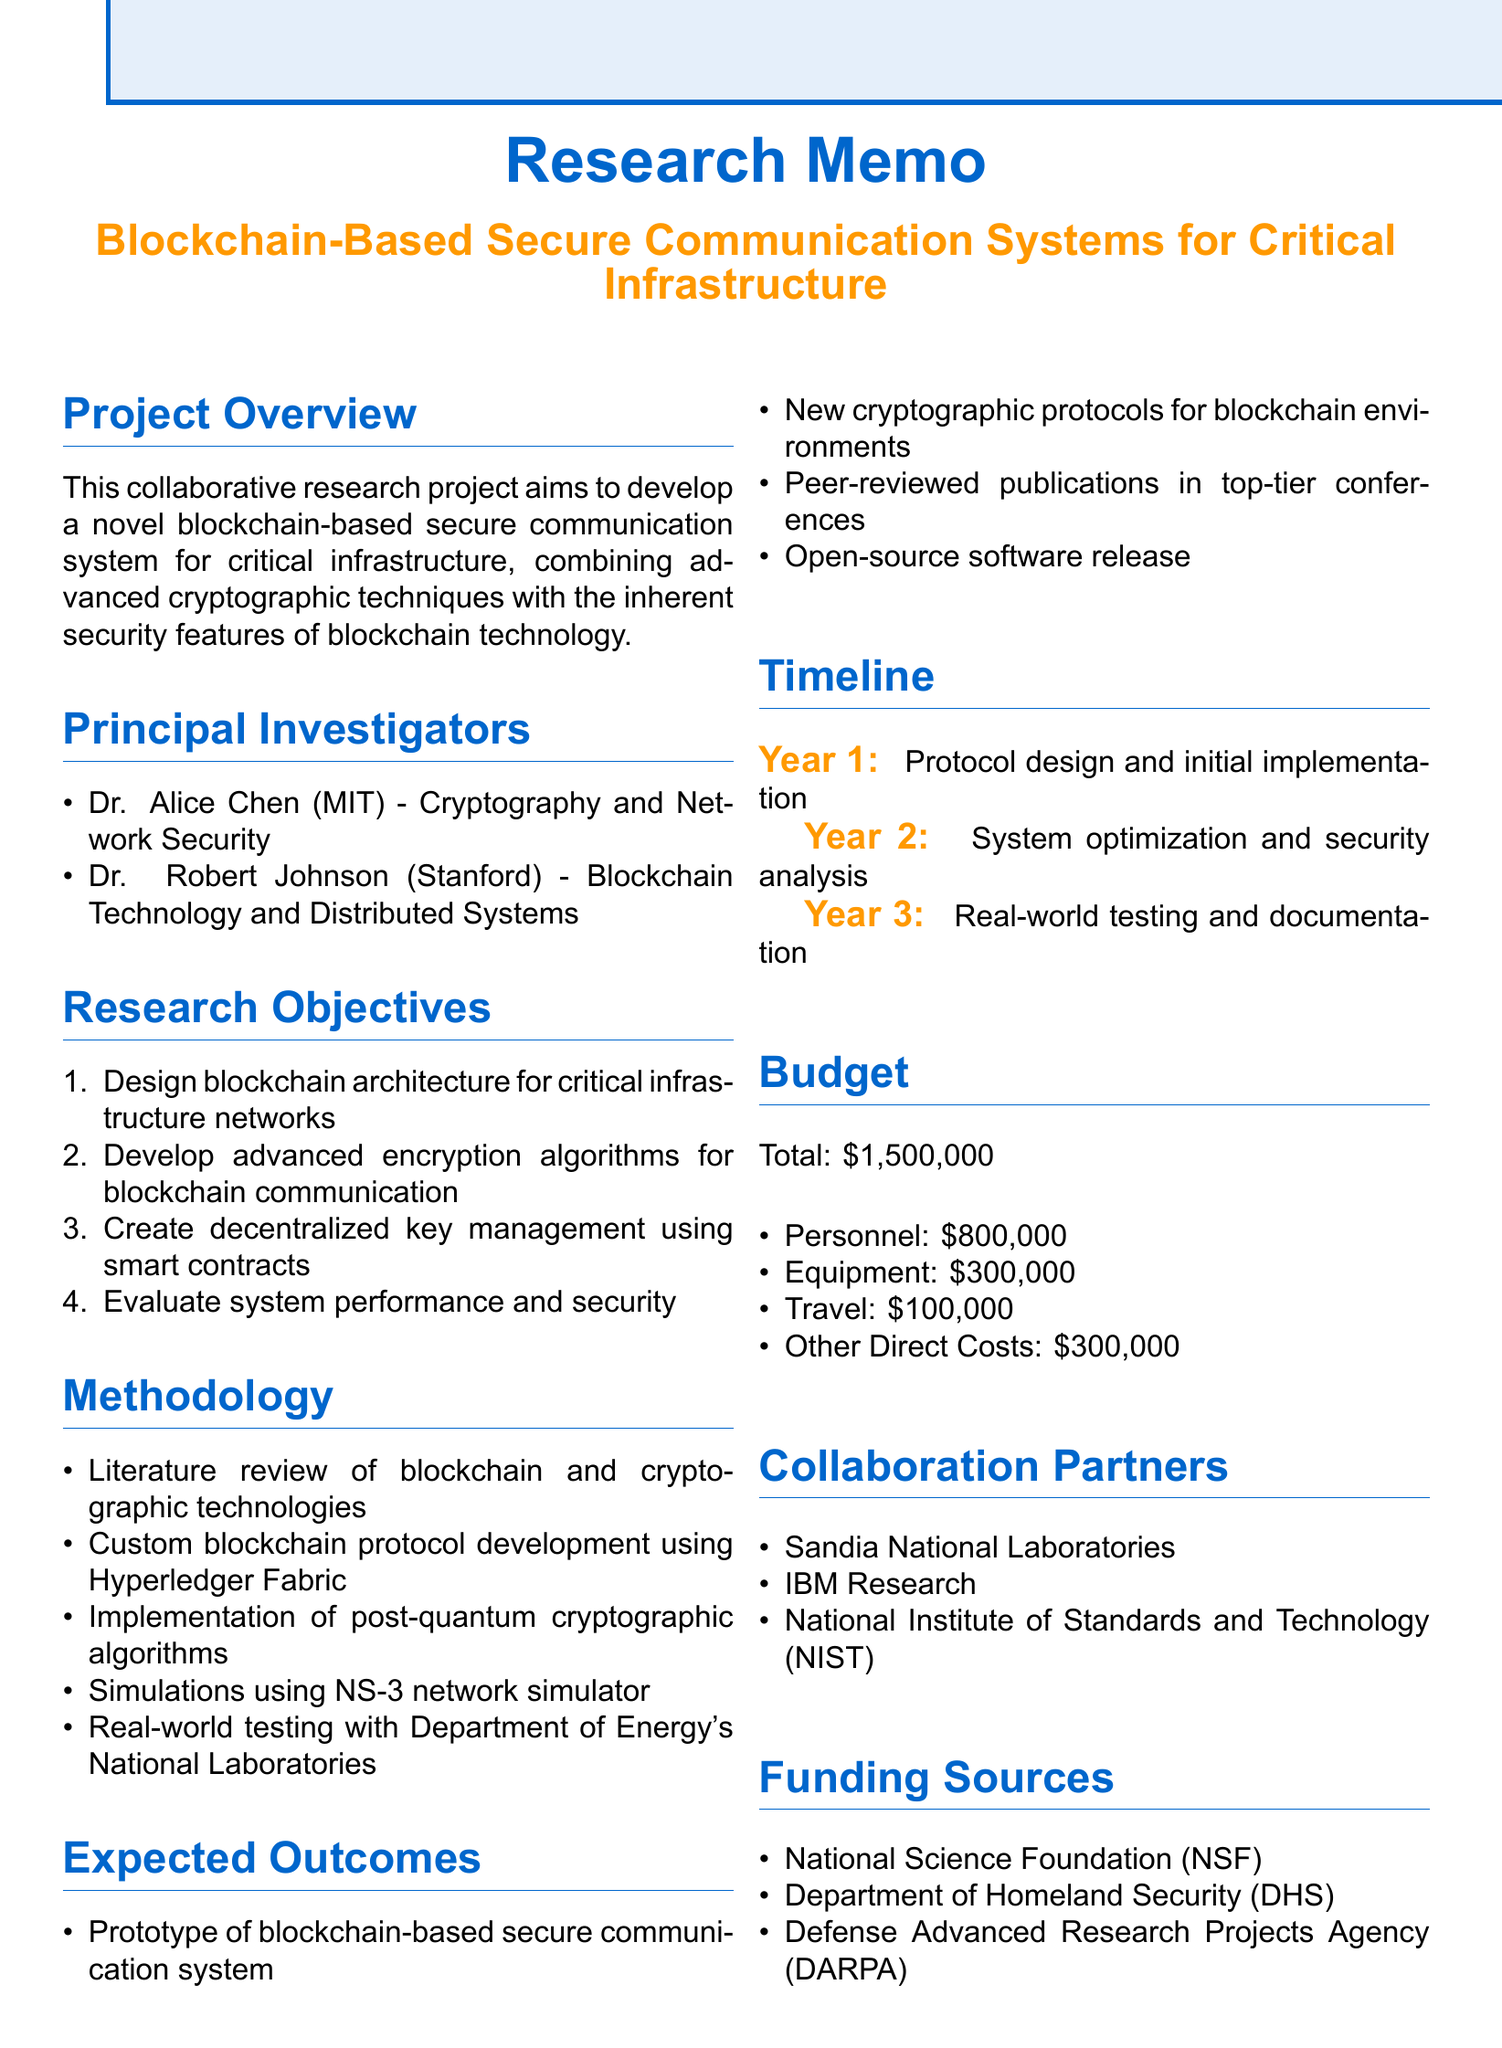What is the title of the project? The title of the project is stated at the beginning of the document.
Answer: Blockchain-Based Secure Communication Systems for Critical Infrastructure Who are the principal investigators? The document lists the names and affiliations of the principal investigators.
Answer: Dr. Alice Chen, Dr. Robert Johnson What is the total budget for the project? The total budget is explicitly mentioned in the budget section of the document.
Answer: $1,500,000 In which year is the protocol design scheduled to be completed? The timeline section indicates activities planned for each year of the project.
Answer: Year 1 What organization is providing domain expertise as a collaboration partner? Collaboration partners are mentioned in a specific section of the document.
Answer: Sandia National Laboratories What methodology involves simulations? The methodology section describes various activities; one specifies the type of testing.
Answer: Simulations using NS-3 network simulator What is one expected outcome of the project? The expected outcomes are listed clearly within the respective section.
Answer: A prototype of a blockchain-based secure communication system Which agency is one of the funding sources? Funding sources are mentioned towards the end of the document; one can be identified easily.
Answer: National Science Foundation (NSF) Which cryptographic algorithms will be implemented? The specific type of cryptographic algorithms is stated in the methodology section.
Answer: Post-quantum cryptographic algorithms 